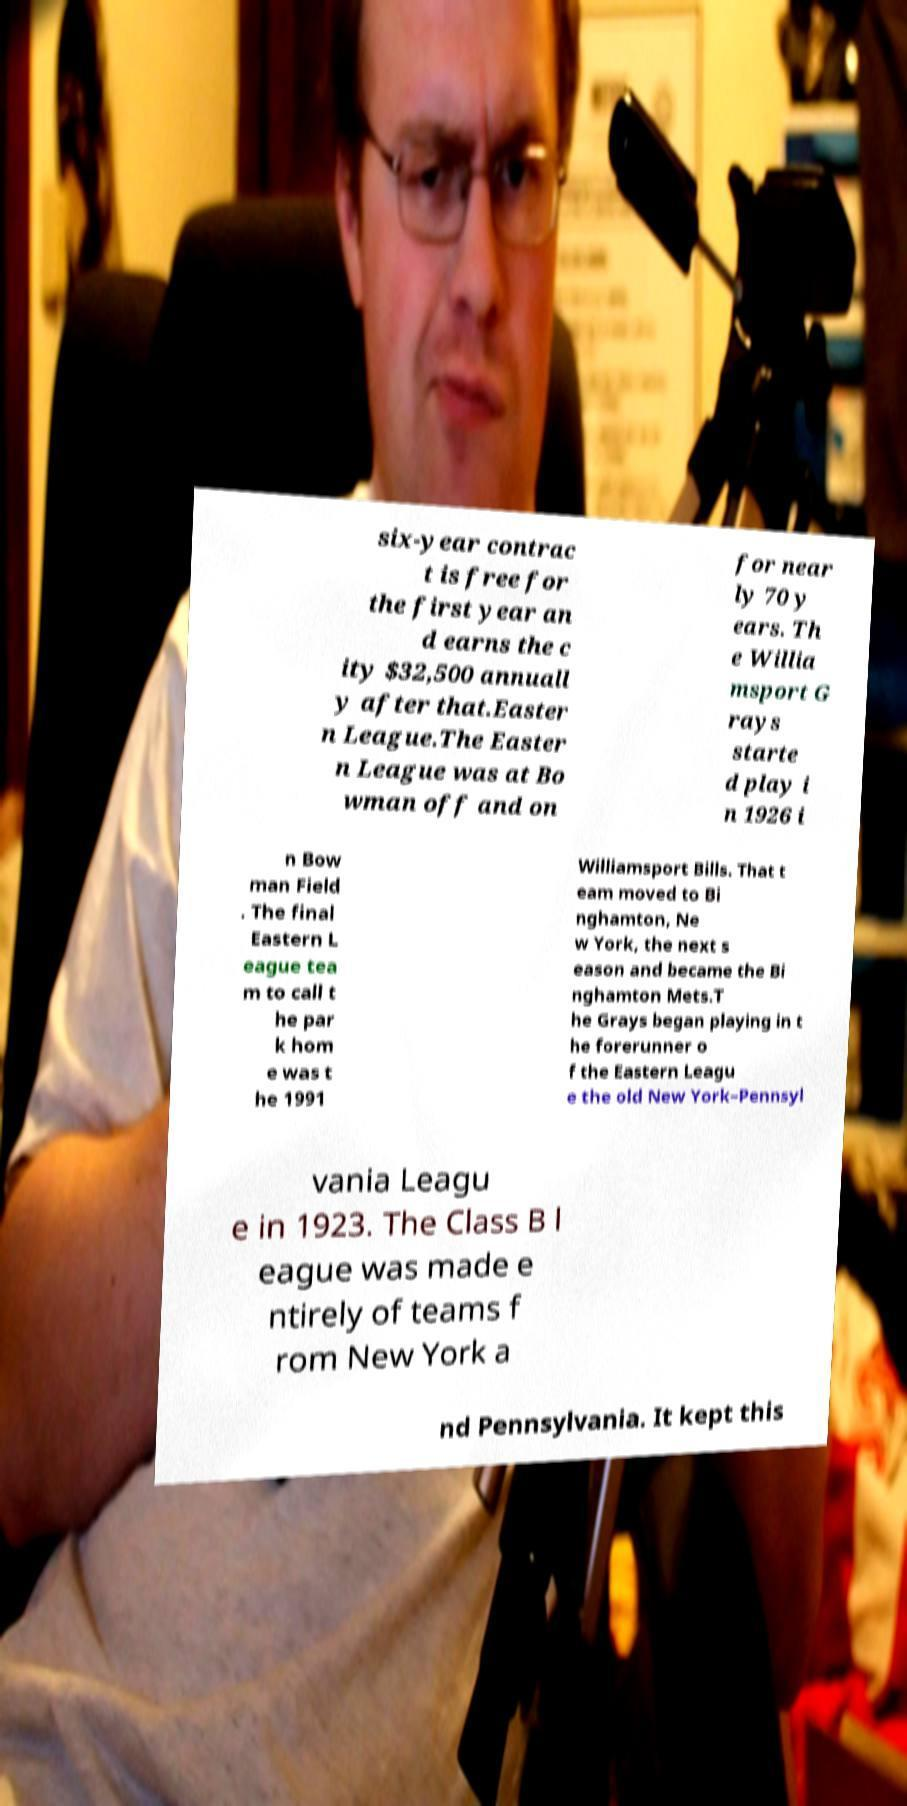For documentation purposes, I need the text within this image transcribed. Could you provide that? six-year contrac t is free for the first year an d earns the c ity $32,500 annuall y after that.Easter n League.The Easter n League was at Bo wman off and on for near ly 70 y ears. Th e Willia msport G rays starte d play i n 1926 i n Bow man Field . The final Eastern L eague tea m to call t he par k hom e was t he 1991 Williamsport Bills. That t eam moved to Bi nghamton, Ne w York, the next s eason and became the Bi nghamton Mets.T he Grays began playing in t he forerunner o f the Eastern Leagu e the old New York–Pennsyl vania Leagu e in 1923. The Class B l eague was made e ntirely of teams f rom New York a nd Pennsylvania. It kept this 